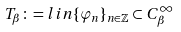Convert formula to latex. <formula><loc_0><loc_0><loc_500><loc_500>T _ { \beta } \colon = l i n \{ \varphi _ { n } \} _ { n \in \mathbb { Z } } \subset C _ { \beta } ^ { \infty }</formula> 